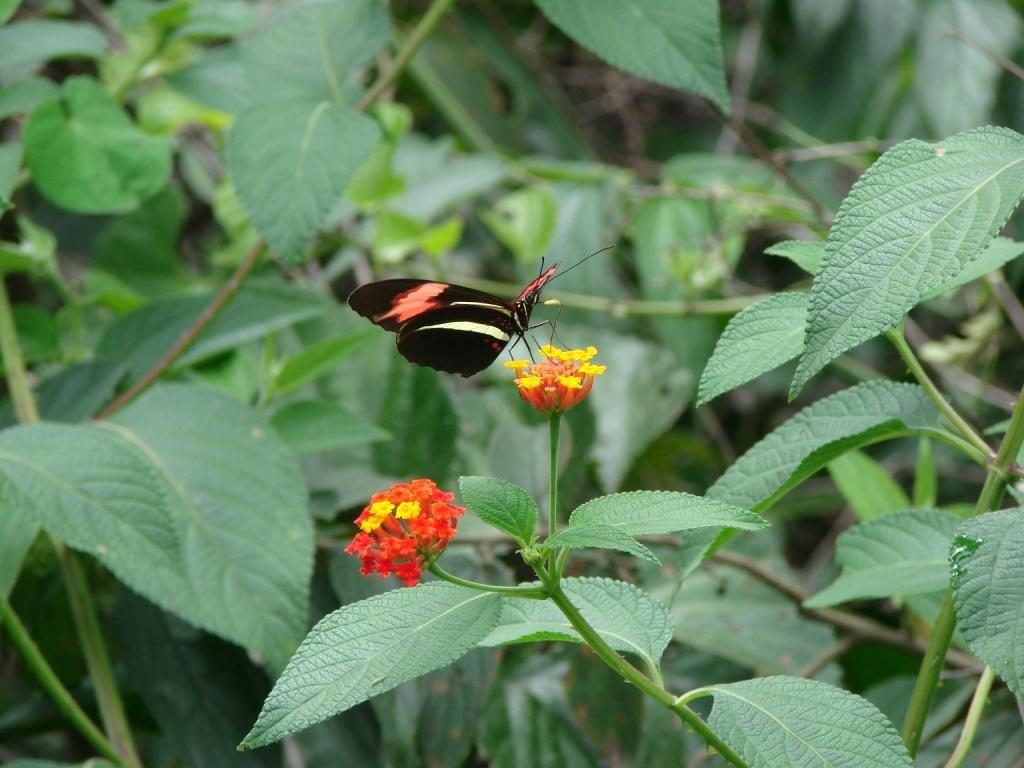What is the main subject of the image? The main subject of the image is a butterfly. Where is the butterfly located in the image? The butterfly is on flowers in the image. What else can be seen in the image besides the butterfly? There are plants with leaves in the image. What type of art can be seen in the background of the image? There is no art present in the image; it features a butterfly on flowers and plants with leaves. How many beads are visible on the butterfly in the image? There are no beads present on the butterfly in the image; it is a natural butterfly. 